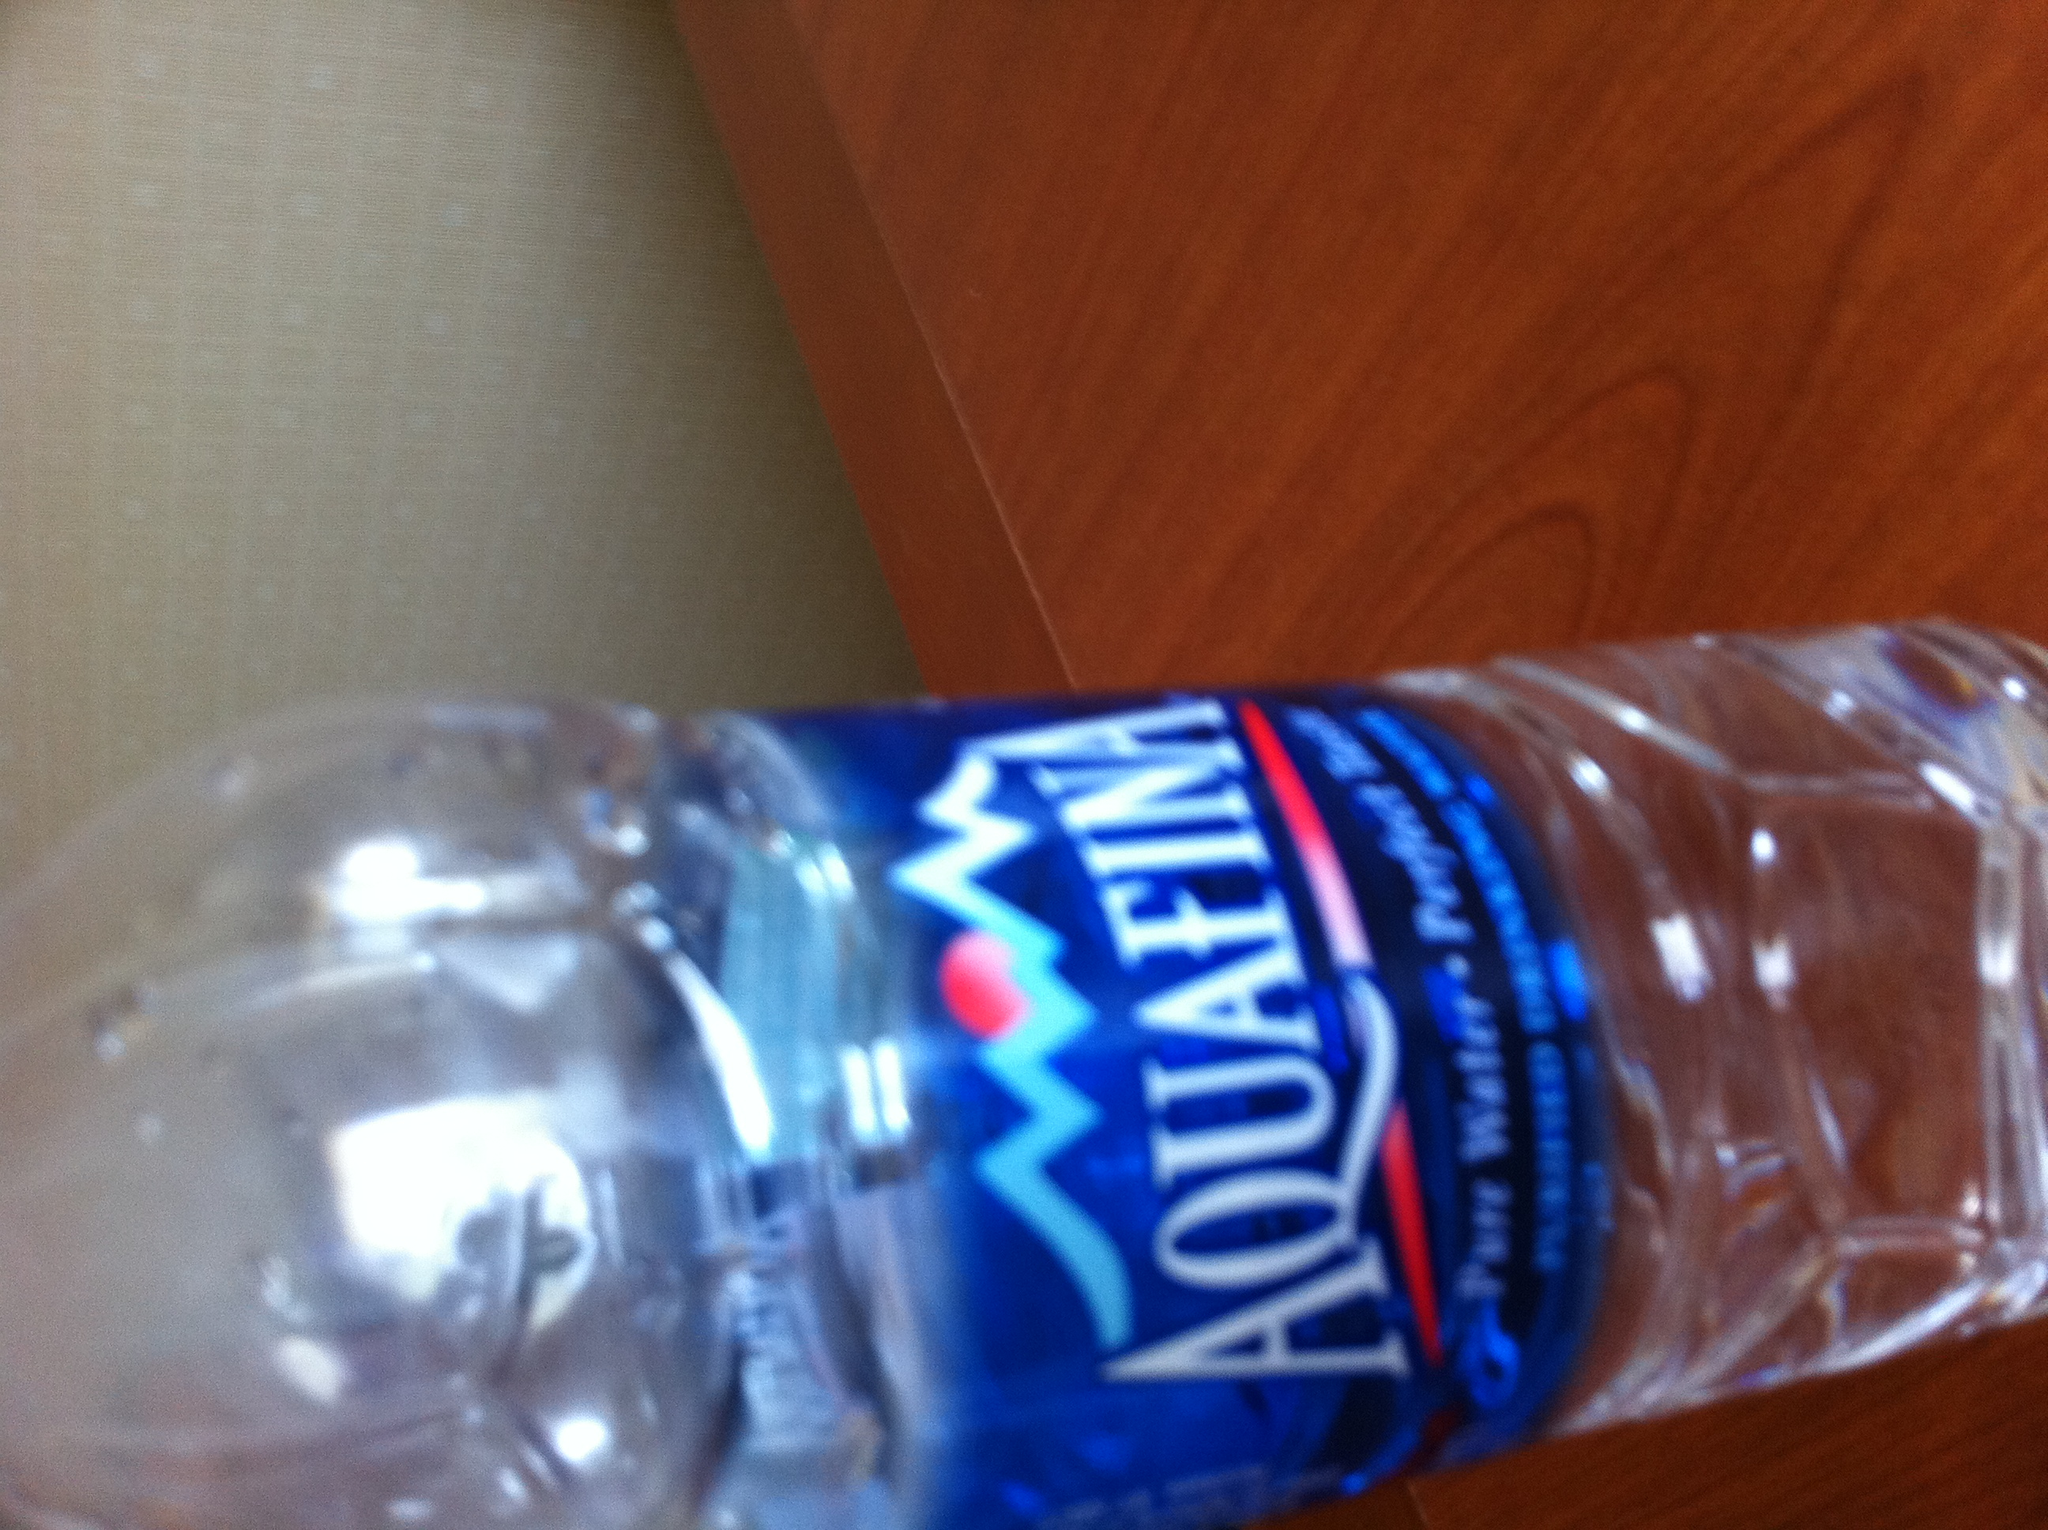What impact do plastic bottles like this have on the environment? Plastic bottles can have significant environmental impacts as they often end up in landfills or as litter, where they can take hundreds of years to break down. It is important to recycle them whenever possible to mitigate these effects. Are there any alternatives to single-use plastic bottles? Certainly. Reusable water bottles made of materials like stainless steel, glass, or BPA-free plastic are a more sustainable choice. They can be refilled multiple times and reduce the reliance on single-use plastics. 